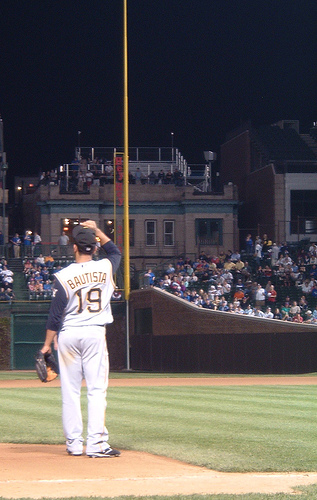Each image has something going on. Carefully analyze the image and generate 5 captions for each image. Caption 1: Under the gleam of stadium lights, 'BAUTISTA' stands solitary at third base, ready as the crowd's excitement builds around him.
Caption 2: Wearing jersey number 19, the player looks over the baseball field, poised in concentration amidst the roar of the eager spectators.
Caption 3: The evening deepens, casting the ballpark under a nocturnal spell while one player remains alert along the third baseline.
Caption 4: 'BAUTISTA', outlined against the illuminated field, showcases the dedication and focus that epitomize the essence of baseball.
Caption 5: Surrounded by a lively audience, a lone figure dominates the field, strategically positioned in anticipation of the game's next turning point. 